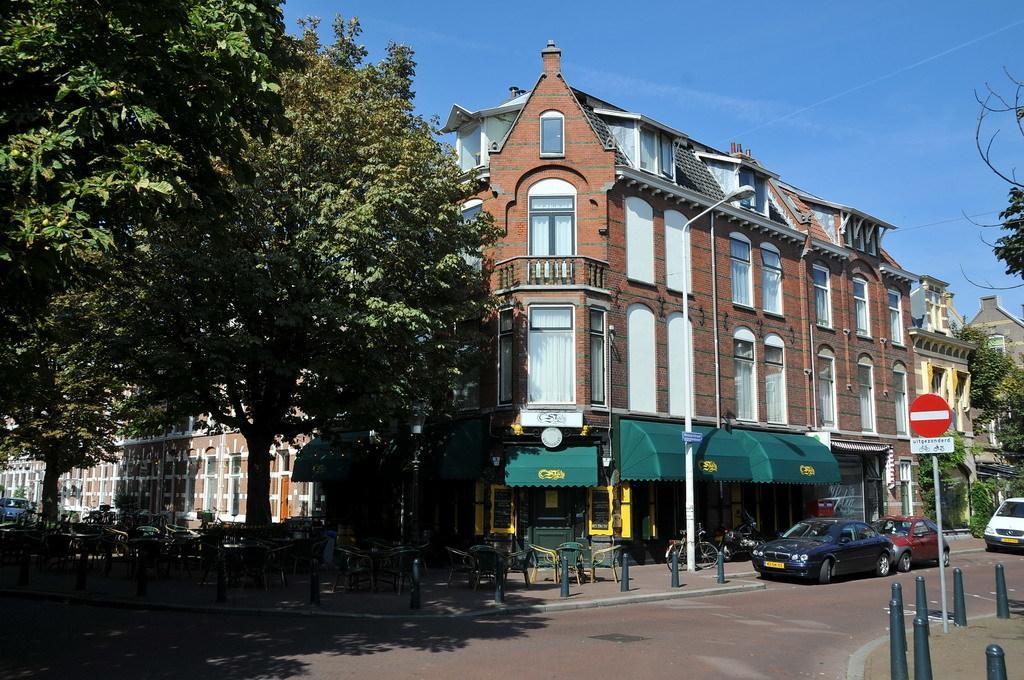In one or two sentences, can you explain what this image depicts? In the image we can see there are many buildings and these are the windows of the buildings. There are even vehicles on the road, these are the poles and there are even trees around. Here we can see a sky. 